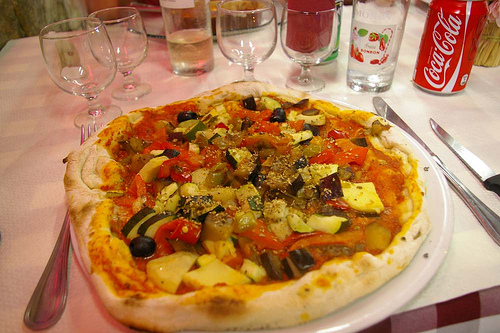Is the utensil by the plate gold or silver? The utensil by the plate has a sleek, reflective silver finish, adding a touch of elegance to the table setting. 